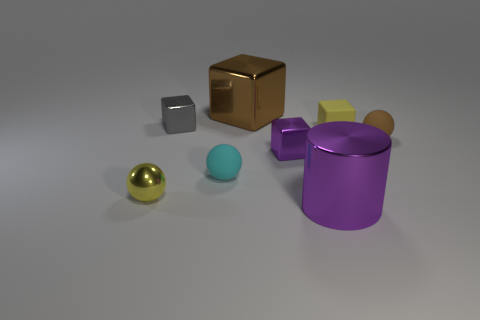What materials are the objects in the image likely made of? The objects in the image exhibit varying sheens and reflectivity, suggesting they might be made from materials like rubber, metal, or plastic. 